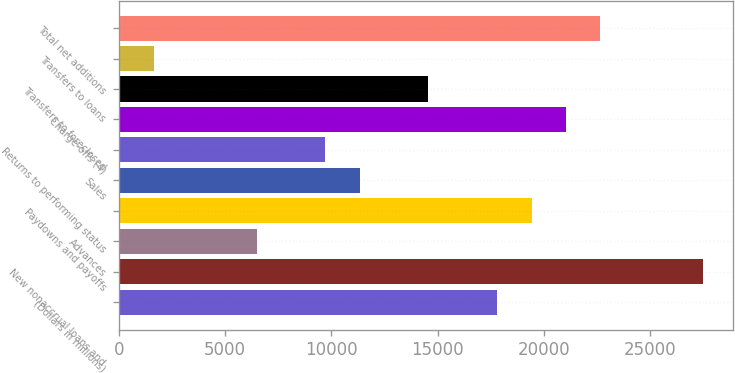Convert chart to OTSL. <chart><loc_0><loc_0><loc_500><loc_500><bar_chart><fcel>(Dollars in millions)<fcel>New nonaccrual loans and<fcel>Advances<fcel>Paydowns and payoffs<fcel>Sales<fcel>Returns to performing status<fcel>Charge-offs (4)<fcel>Transfers to foreclosed<fcel>Transfers to loans<fcel>Total net additions<nl><fcel>17808.6<fcel>27520.2<fcel>6478.4<fcel>19427.2<fcel>11334.2<fcel>9715.6<fcel>21045.8<fcel>14571.4<fcel>1622.6<fcel>22664.4<nl></chart> 